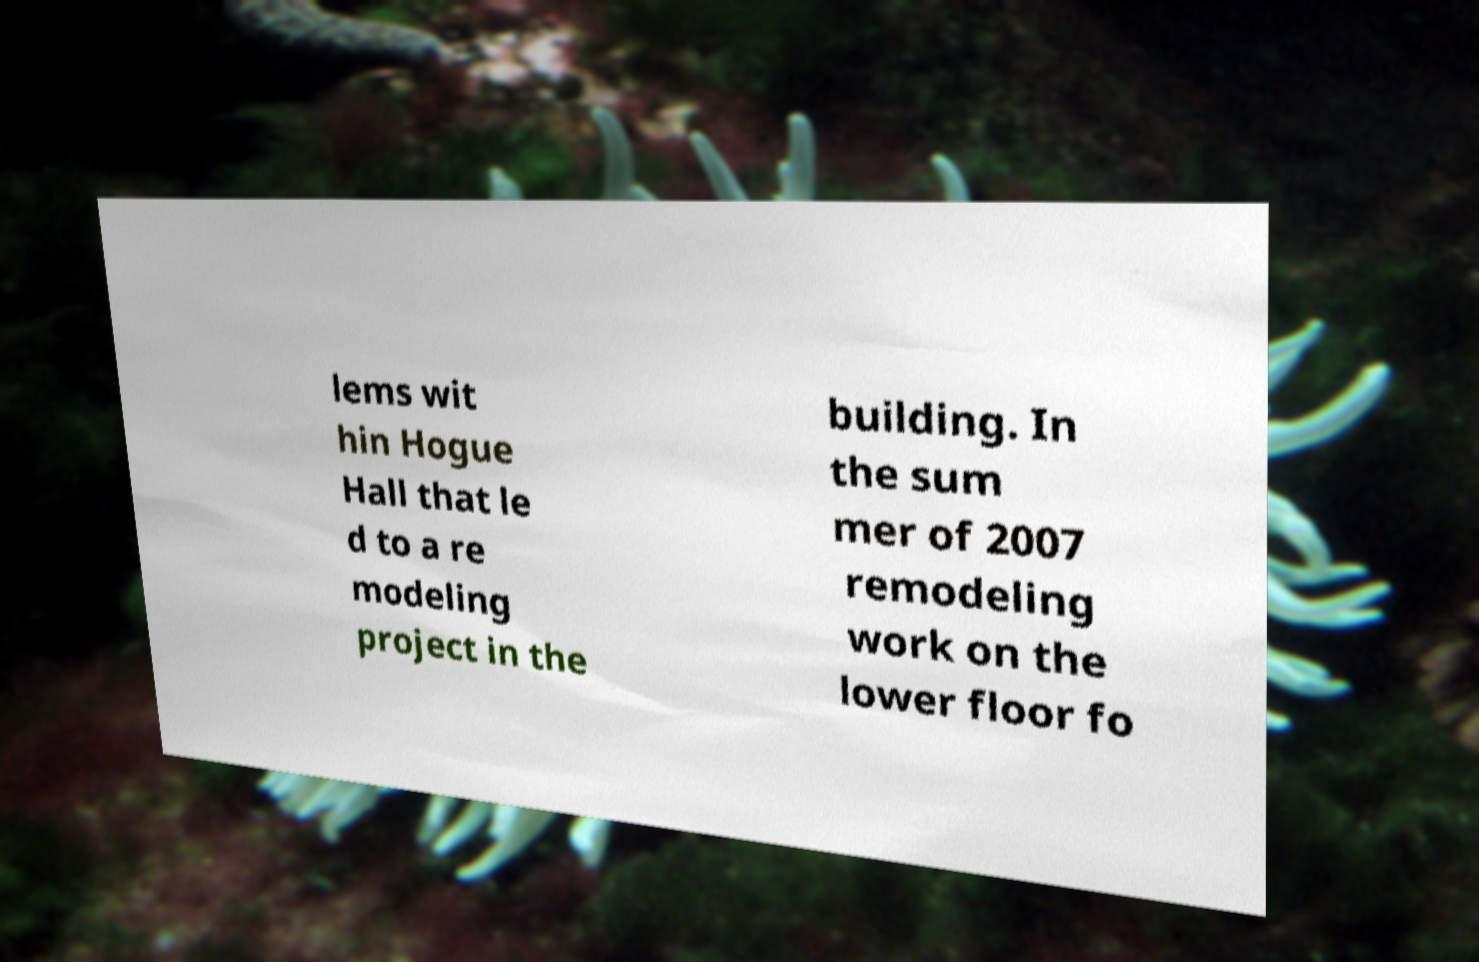Can you read and provide the text displayed in the image?This photo seems to have some interesting text. Can you extract and type it out for me? lems wit hin Hogue Hall that le d to a re modeling project in the building. In the sum mer of 2007 remodeling work on the lower floor fo 